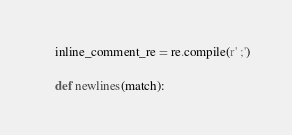<code> <loc_0><loc_0><loc_500><loc_500><_Python_>    inline_comment_re = re.compile(r' ;')

    def newlines(match):</code> 